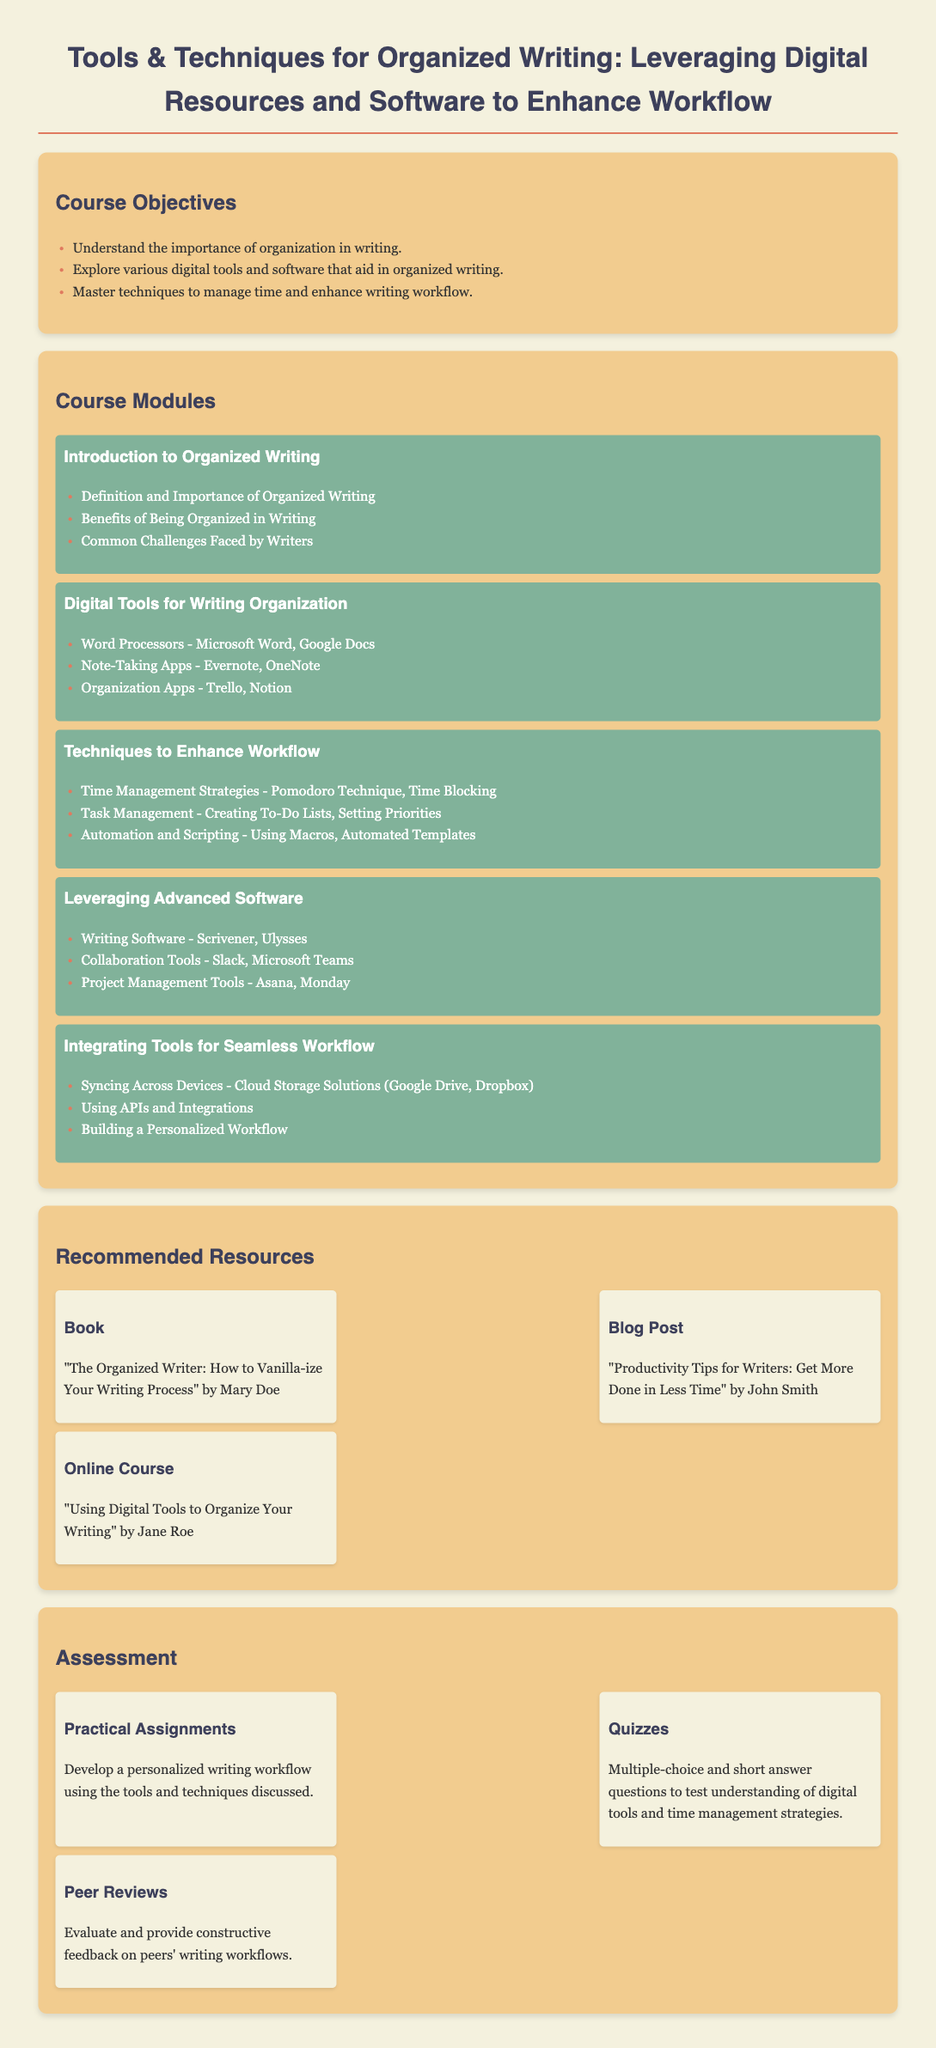What is the course title? The course title is the main heading of the document, which provides an overview of the subject matter.
Answer: Tools & Techniques for Organized Writing: Leveraging Digital Resources and Software to Enhance Workflow What is one of the course objectives? The course objectives are listed in bullet points under the relevant section.
Answer: Understand the importance of organization in writing Name one digital tool for writing organization mentioned in the syllabus. Digital tools for writing organization are specifically outlined in one of the course modules.
Answer: Microsoft Word What is a technique to enhance workflow discussed in the course? Techniques to enhance workflow are described under a designated module in the syllabus.
Answer: Pomodoro Technique What is the title of one recommended book? Recommended resources provide specific titles under the relevant section.
Answer: The Organized Writer: How to Vanilla-ize Your Writing Process How many practical assignments are listed in the assessment section? The assessment section outlines the types of assignments presented to students.
Answer: One What is one collaboration tool mentioned in the course? The course lists collaborative tools as part of the advanced software module.
Answer: Slack What type of feedback is involved in peer reviews? The assessment section specifies the nature of the feedback expected during peer reviews.
Answer: Constructive feedback Which app is listed under organization apps? Organization apps are described in detail under the digital tools module.
Answer: Trello 